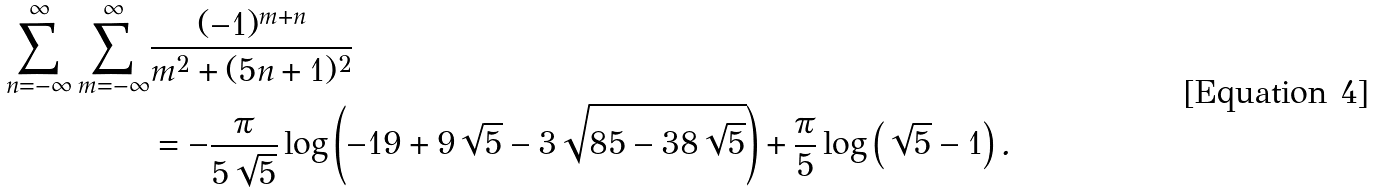<formula> <loc_0><loc_0><loc_500><loc_500>\sum _ { n = - \infty } ^ { \infty } \sum _ { m = - \infty } ^ { \infty } & \frac { ( - 1 ) ^ { m + n } } { m ^ { 2 } + ( 5 n + 1 ) ^ { 2 } } \\ & = - \frac { \pi } { 5 \sqrt { 5 } } \log \left ( - 1 9 + 9 \sqrt { 5 } - 3 \sqrt { 8 5 - 3 8 \sqrt { 5 } } \right ) + \frac { \pi } { 5 } \log \left ( \sqrt { 5 } - 1 \right ) .</formula> 